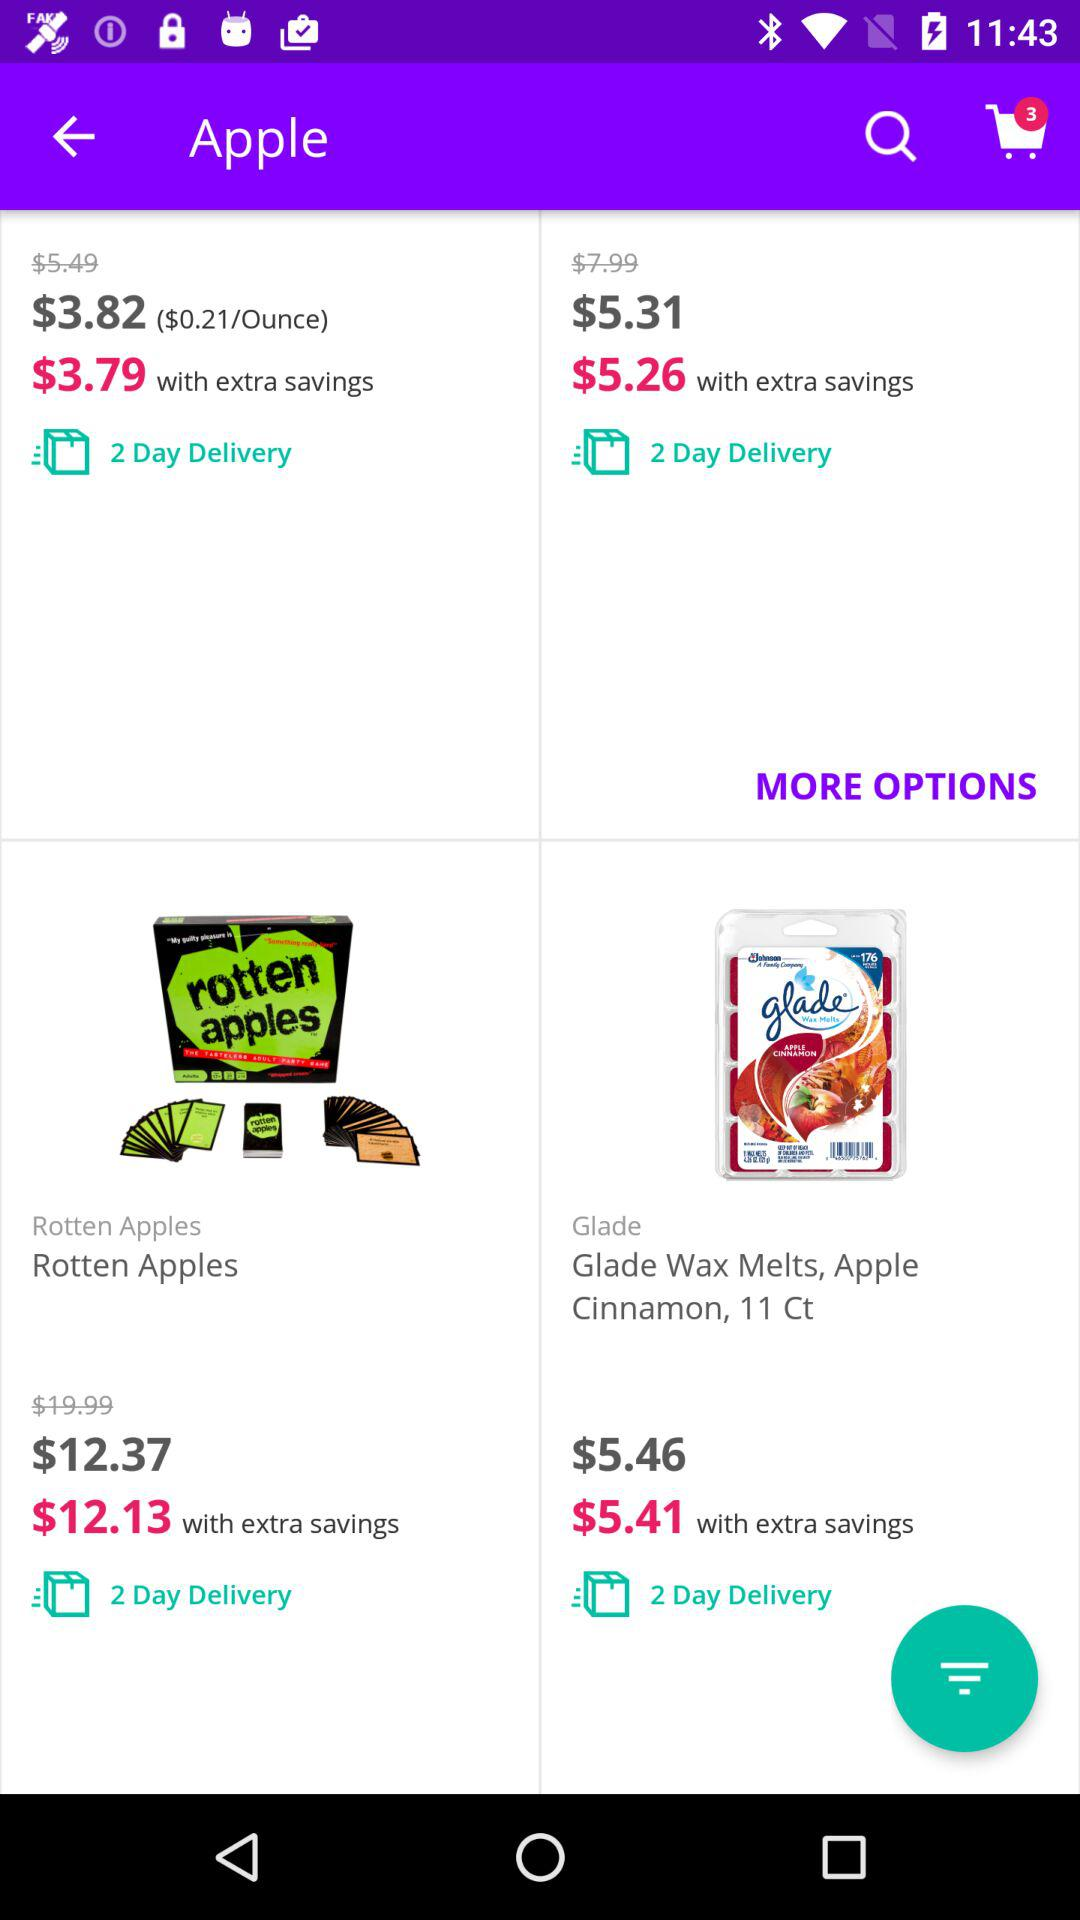How many days will it take to deliver the rotten apples? It will take 2 days to deliver the rotten apples. 